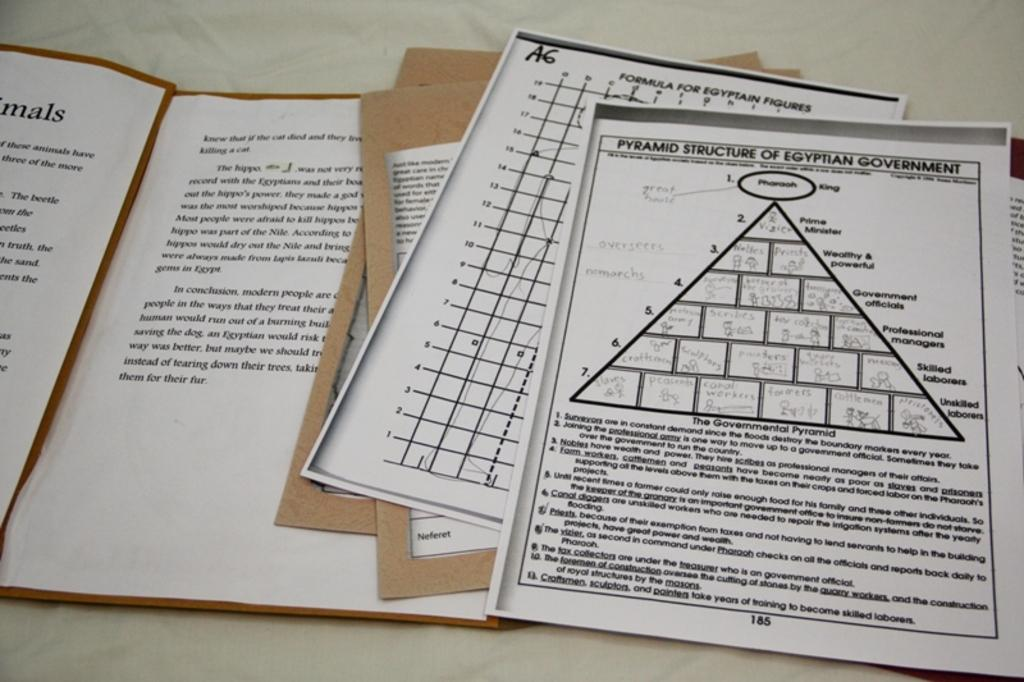<image>
Offer a succinct explanation of the picture presented. A group of white sheets with the top image reading Pyramid Structure on it. 